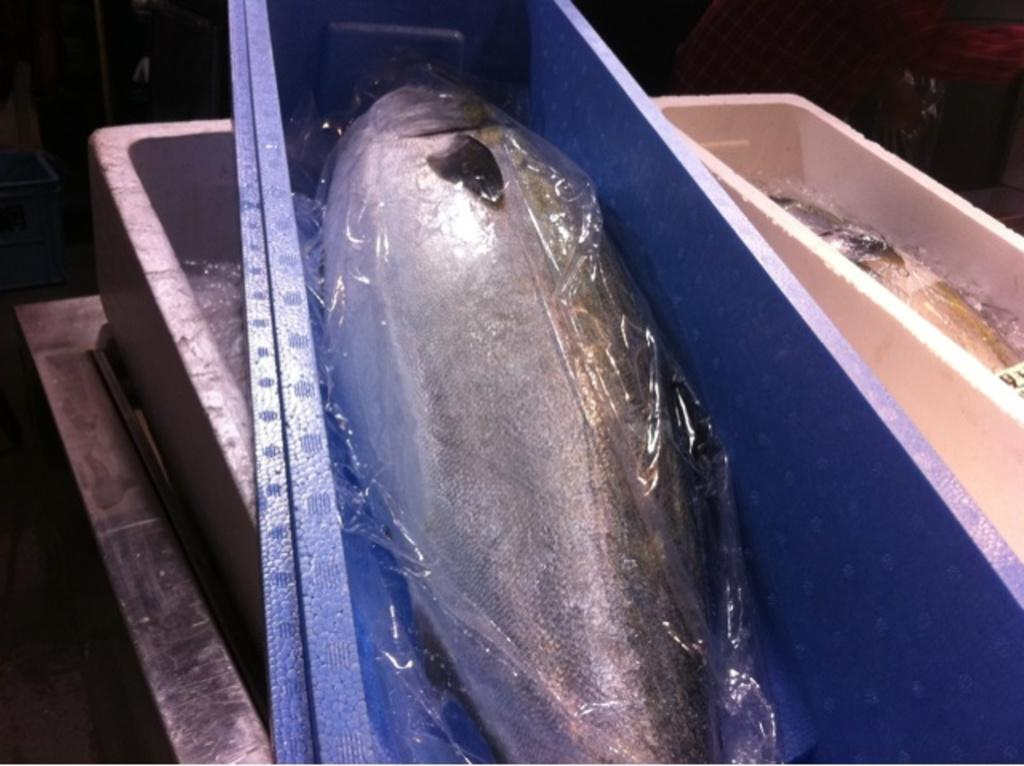What type of animals are in the image? There are fishes in the image. How are the fishes contained in the image? The fishes are in boxes. What is used to cover the boxes in the image? The boxes have a plastic cover. What material are the boxes made of? The boxes are made of thermocol. What type of government is depicted in the image? There is no depiction of a government in the image; it features fishes in boxes. How much honey is present in the image? There is no honey present in the image; it features fishes in boxes. 